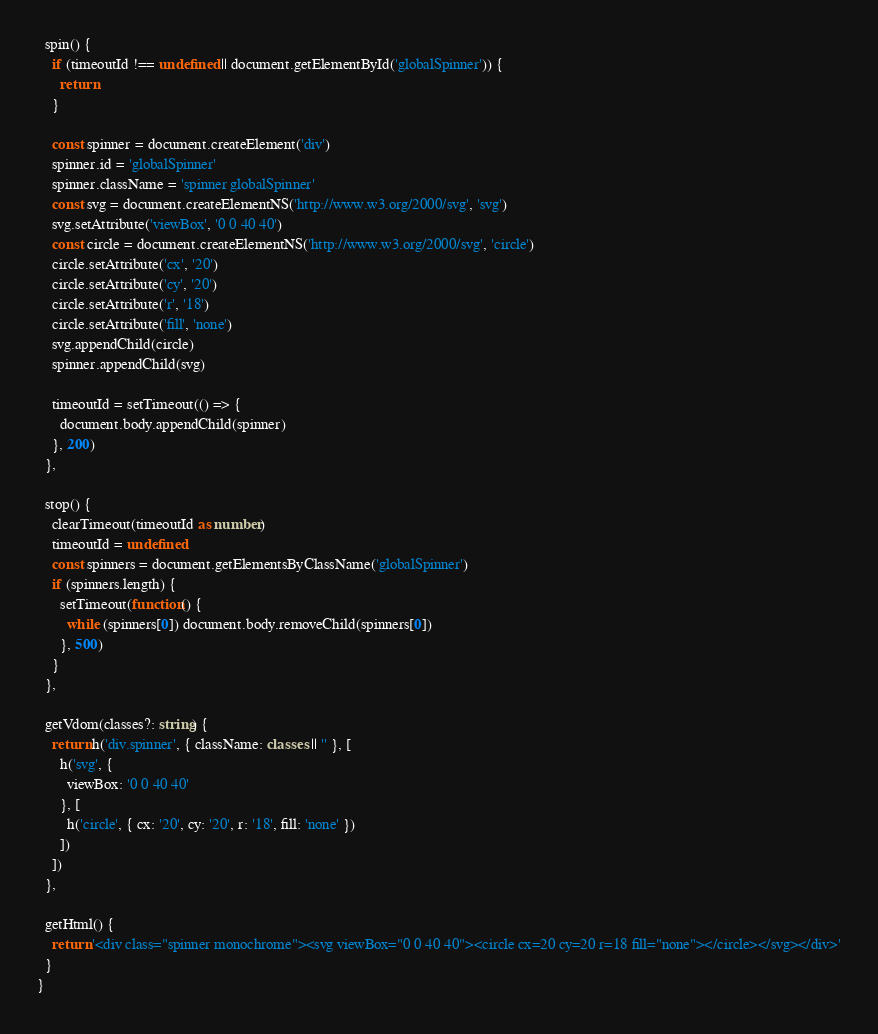<code> <loc_0><loc_0><loc_500><loc_500><_TypeScript_>  spin() {
    if (timeoutId !== undefined || document.getElementById('globalSpinner')) {
      return
    }

    const spinner = document.createElement('div')
    spinner.id = 'globalSpinner'
    spinner.className = 'spinner globalSpinner'
    const svg = document.createElementNS('http://www.w3.org/2000/svg', 'svg')
    svg.setAttribute('viewBox', '0 0 40 40')
    const circle = document.createElementNS('http://www.w3.org/2000/svg', 'circle')
    circle.setAttribute('cx', '20')
    circle.setAttribute('cy', '20')
    circle.setAttribute('r', '18')
    circle.setAttribute('fill', 'none')
    svg.appendChild(circle)
    spinner.appendChild(svg)

    timeoutId = setTimeout(() => {
      document.body.appendChild(spinner)
    }, 200)
  },

  stop() {
    clearTimeout(timeoutId as number)
    timeoutId = undefined
    const spinners = document.getElementsByClassName('globalSpinner')
    if (spinners.length) {
      setTimeout(function() {
        while (spinners[0]) document.body.removeChild(spinners[0])
      }, 500)
    }
  },

  getVdom(classes?: string) {
    return h('div.spinner', { className: classes || '' }, [
      h('svg', {
        viewBox: '0 0 40 40'
      }, [
        h('circle', { cx: '20', cy: '20', r: '18', fill: 'none' })
      ])
    ])
  },

  getHtml() {
    return '<div class="spinner monochrome"><svg viewBox="0 0 40 40"><circle cx=20 cy=20 r=18 fill="none"></circle></svg></div>'
  }
}
</code> 